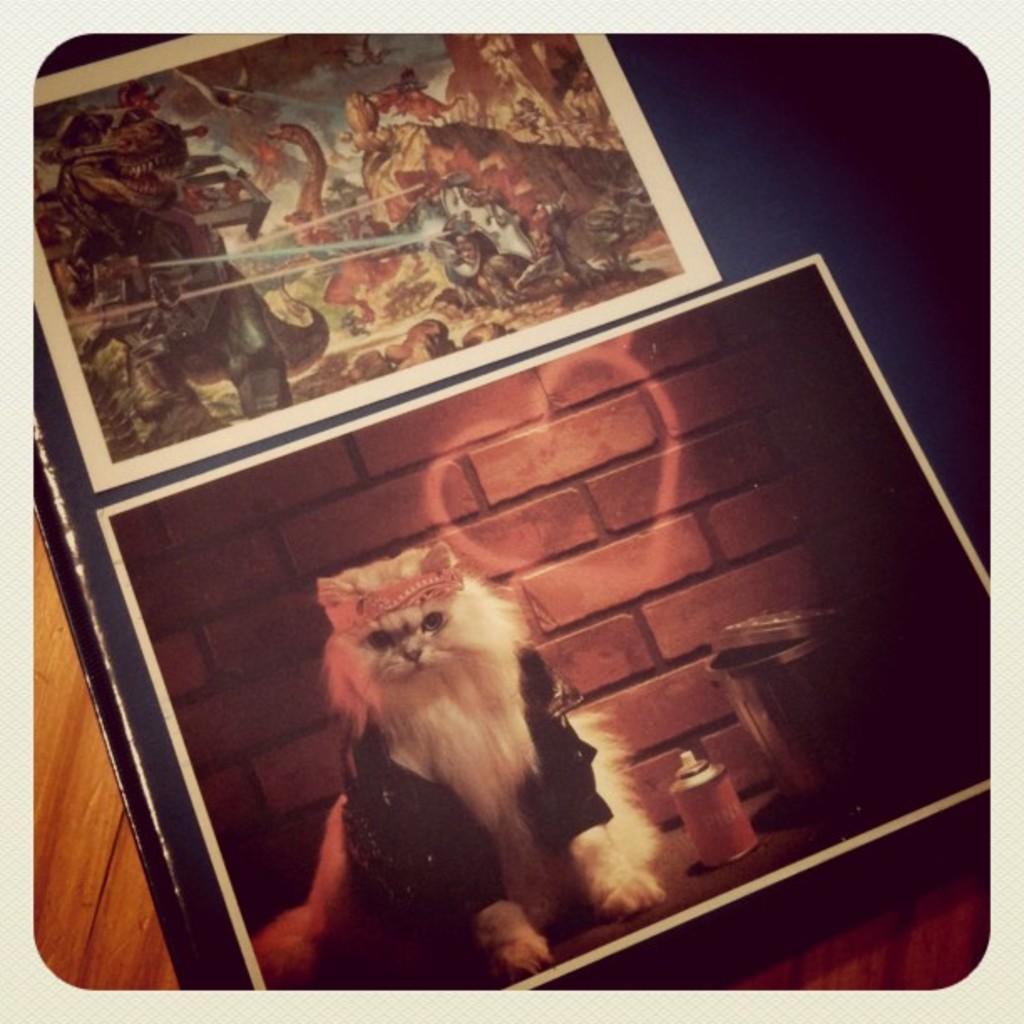Could you give a brief overview of what you see in this image? This image consists of frames in which there is a picture of a cat. At the bottom, there is a table made up of wood. 